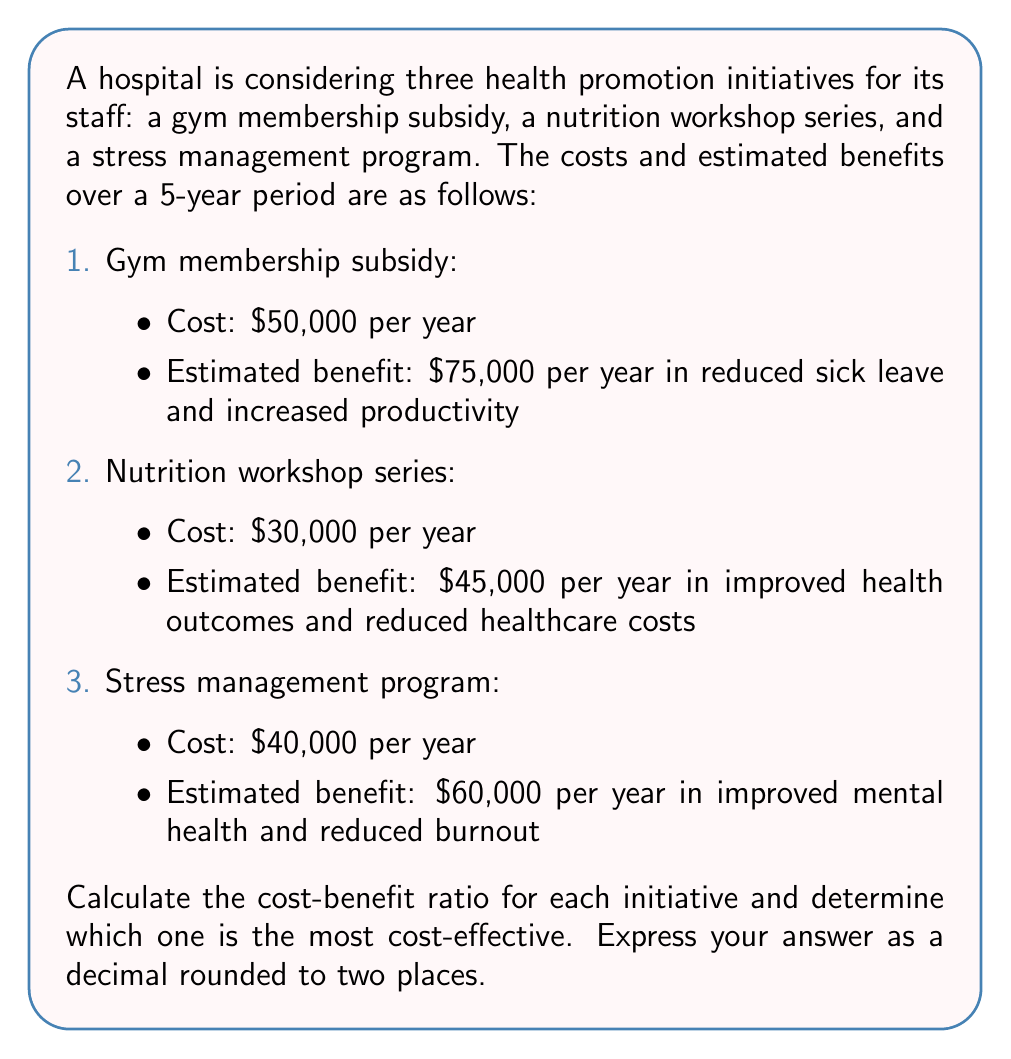Teach me how to tackle this problem. To solve this problem, we need to calculate the cost-benefit ratio for each initiative and compare them. The cost-benefit ratio is calculated by dividing the total benefits by the total costs over the 5-year period.

Let's calculate the ratio for each initiative:

1. Gym membership subsidy:
   Total cost over 5 years: $50,000 × 5 = $250,000
   Total benefit over 5 years: $75,000 × 5 = $375,000
   Cost-benefit ratio: $\frac{375,000}{250,000} = 1.50$

2. Nutrition workshop series:
   Total cost over 5 years: $30,000 × 5 = $150,000
   Total benefit over 5 years: $45,000 × 5 = $225,000
   Cost-benefit ratio: $\frac{225,000}{150,000} = 1.50$

3. Stress management program:
   Total cost over 5 years: $40,000 × 5 = $200,000
   Total benefit over 5 years: $60,000 × 5 = $300,000
   Cost-benefit ratio: $\frac{300,000}{200,000} = 1.50$

All three initiatives have the same cost-benefit ratio of 1.50, which means they are equally cost-effective. For every dollar spent, the hospital expects to receive $1.50 in benefits.

Since all initiatives have the same cost-effectiveness, the hospital may consider implementing all of them or choose based on other factors such as available budget, staff preferences, or specific health needs of the employees.
Answer: 1.50 